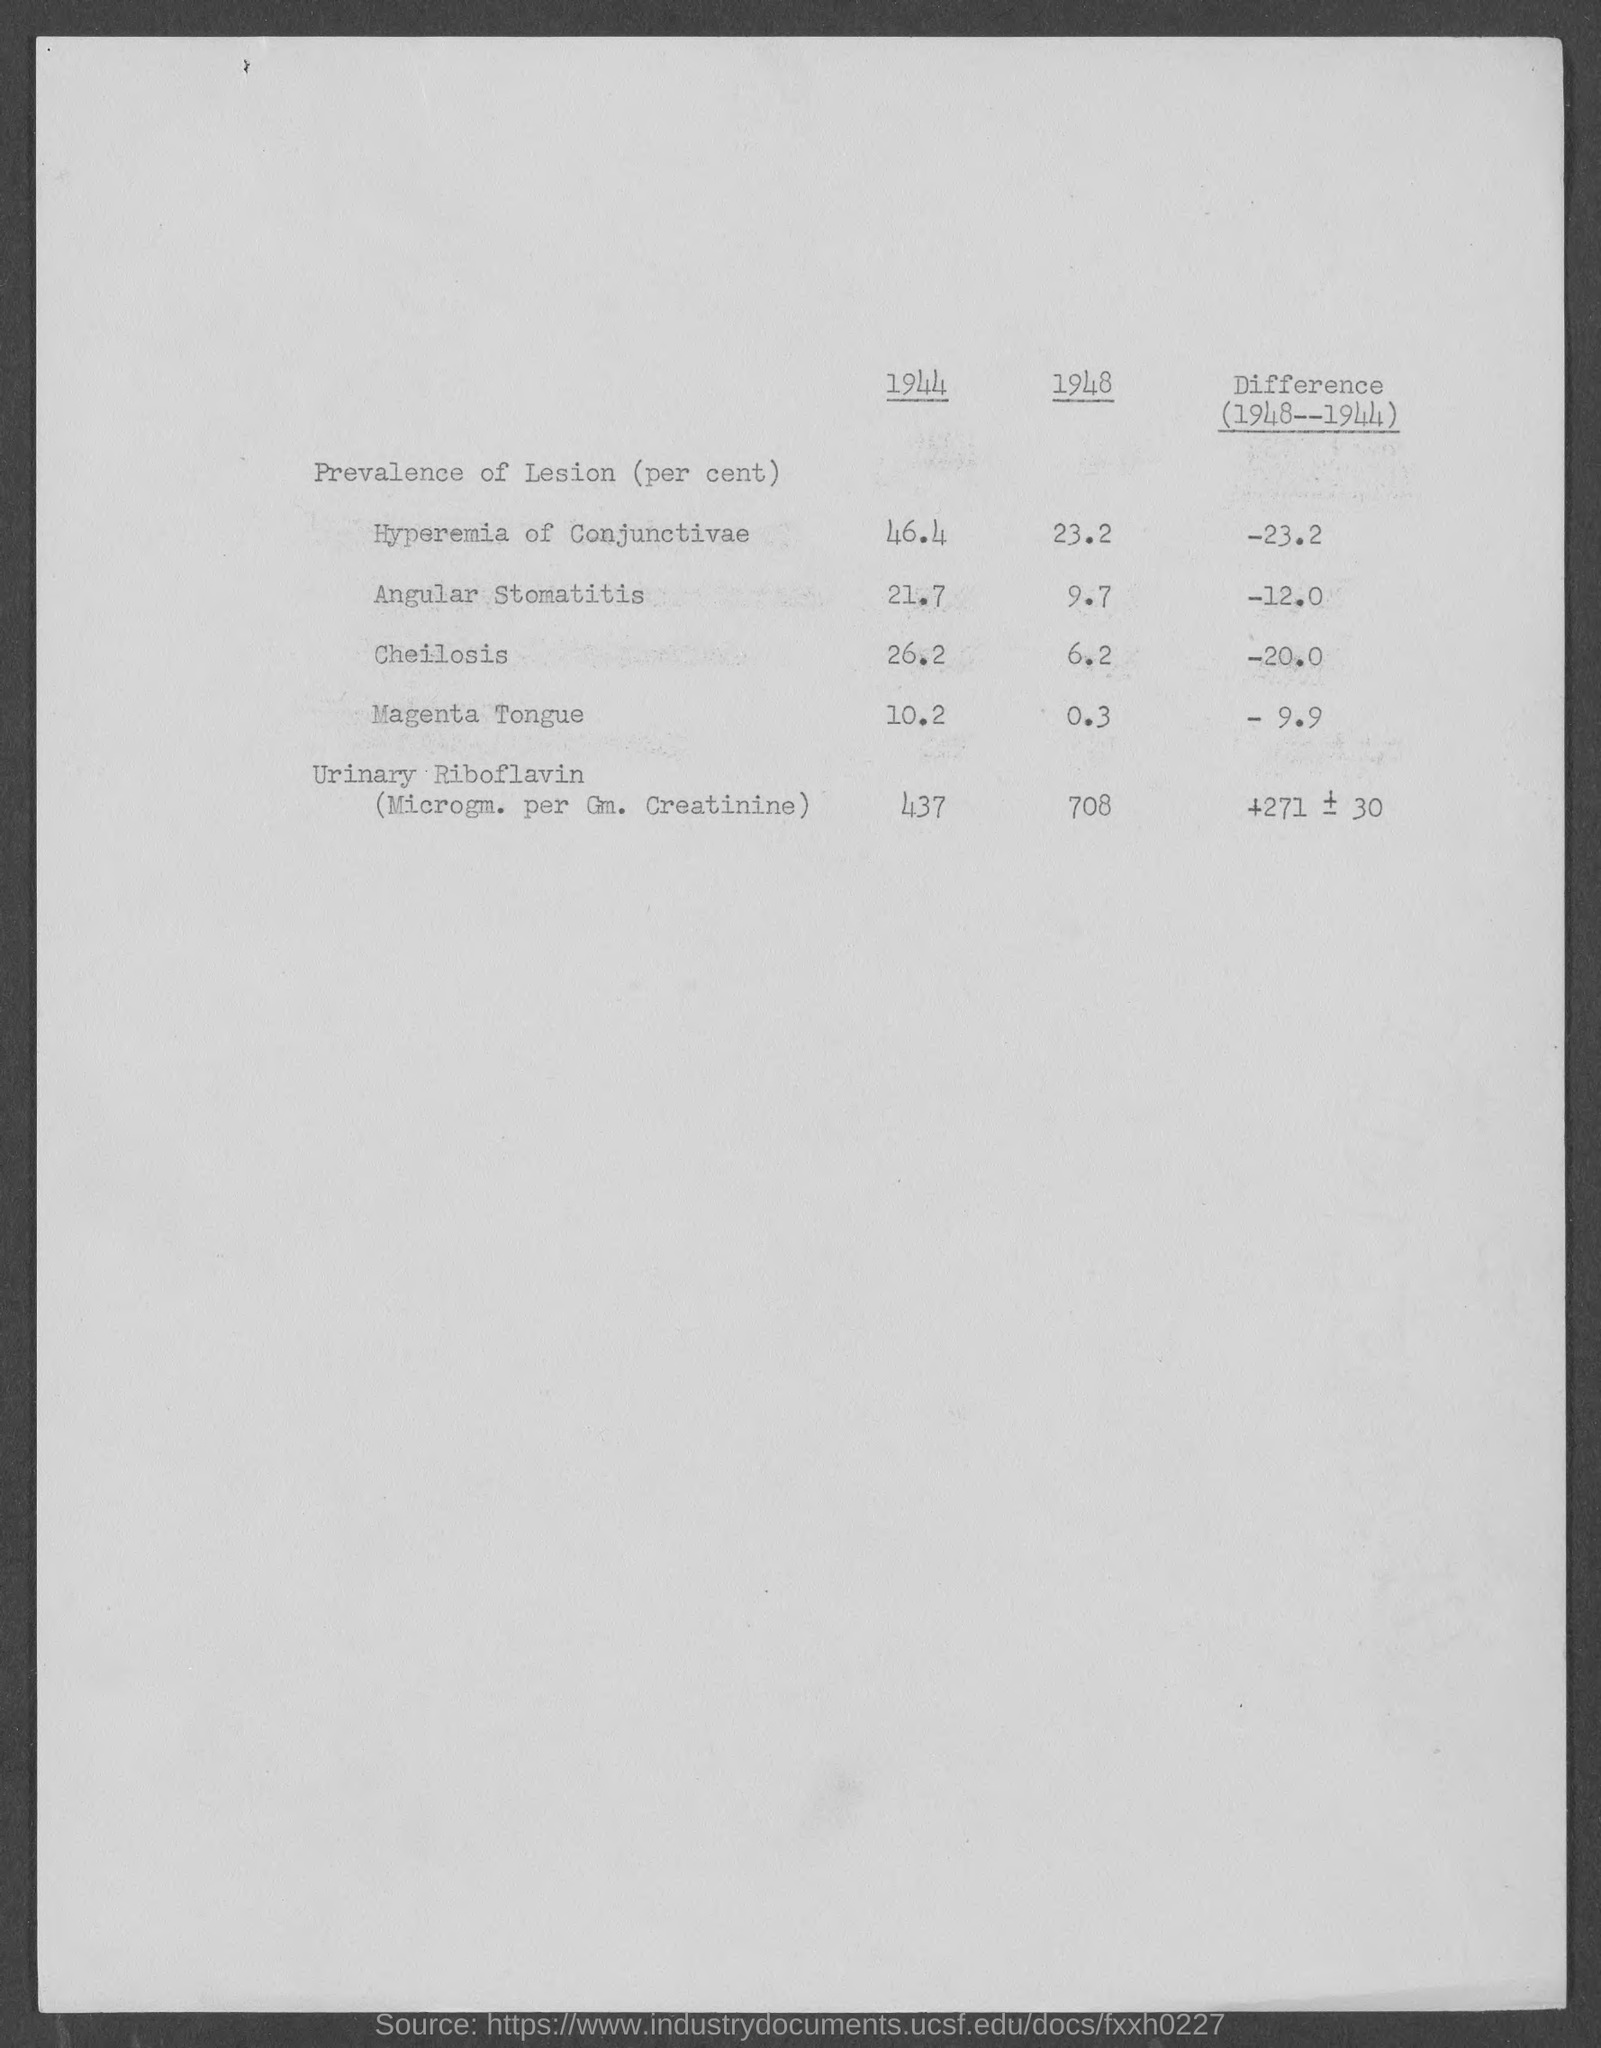Indicate a few pertinent items in this graphic. In the year 1944, the prevalence of lesions in the hyperemia of the conjunctivae was 46.4%. In the year 1944, the prevalence of lesions in individuals with Magenta Tongue was 10.2%. In the year 1948, the prevalence of lesions in cheilosis was 6.2%. 